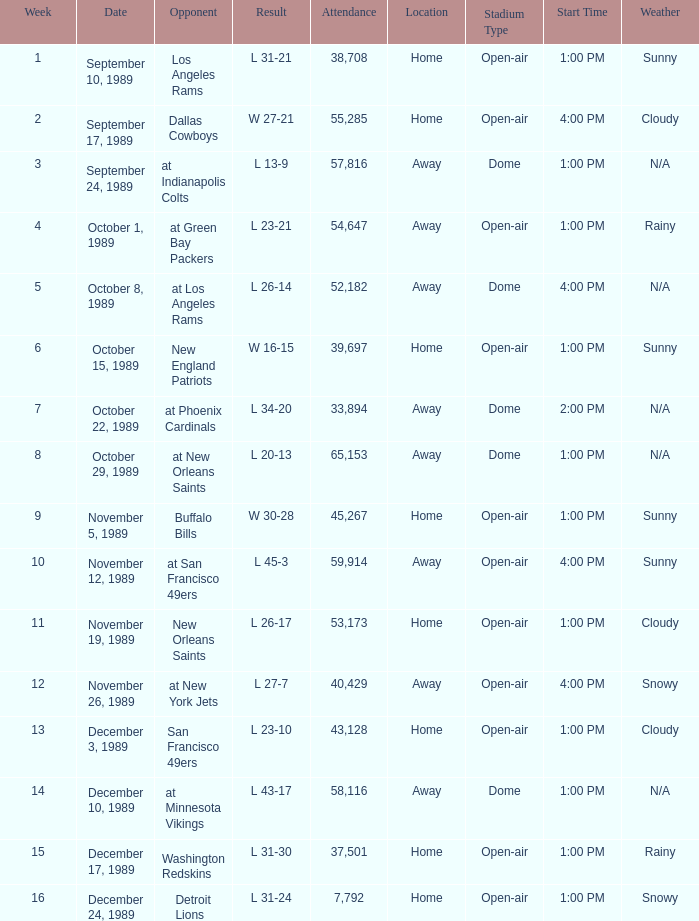For what week was the attendance 40,429? 12.0. Can you give me this table as a dict? {'header': ['Week', 'Date', 'Opponent', 'Result', 'Attendance', 'Location', 'Stadium Type', 'Start Time', 'Weather'], 'rows': [['1', 'September 10, 1989', 'Los Angeles Rams', 'L 31-21', '38,708', 'Home', 'Open-air', '1:00 PM', 'Sunny'], ['2', 'September 17, 1989', 'Dallas Cowboys', 'W 27-21', '55,285', 'Home', 'Open-air', '4:00 PM', 'Cloudy'], ['3', 'September 24, 1989', 'at Indianapolis Colts', 'L 13-9', '57,816', 'Away', 'Dome', '1:00 PM', 'N/A'], ['4', 'October 1, 1989', 'at Green Bay Packers', 'L 23-21', '54,647', 'Away', 'Open-air', '1:00 PM', 'Rainy'], ['5', 'October 8, 1989', 'at Los Angeles Rams', 'L 26-14', '52,182', 'Away', 'Dome', '4:00 PM', 'N/A'], ['6', 'October 15, 1989', 'New England Patriots', 'W 16-15', '39,697', 'Home', 'Open-air', '1:00 PM', 'Sunny'], ['7', 'October 22, 1989', 'at Phoenix Cardinals', 'L 34-20', '33,894', 'Away', 'Dome', '2:00 PM', 'N/A'], ['8', 'October 29, 1989', 'at New Orleans Saints', 'L 20-13', '65,153', 'Away', 'Dome', '1:00 PM', 'N/A'], ['9', 'November 5, 1989', 'Buffalo Bills', 'W 30-28', '45,267', 'Home', 'Open-air', '1:00 PM', 'Sunny'], ['10', 'November 12, 1989', 'at San Francisco 49ers', 'L 45-3', '59,914', 'Away', 'Open-air', '4:00 PM', 'Sunny'], ['11', 'November 19, 1989', 'New Orleans Saints', 'L 26-17', '53,173', 'Home', 'Open-air', '1:00 PM', 'Cloudy'], ['12', 'November 26, 1989', 'at New York Jets', 'L 27-7', '40,429', 'Away', 'Open-air', '4:00 PM', 'Snowy'], ['13', 'December 3, 1989', 'San Francisco 49ers', 'L 23-10', '43,128', 'Home', 'Open-air', '1:00 PM', 'Cloudy'], ['14', 'December 10, 1989', 'at Minnesota Vikings', 'L 43-17', '58,116', 'Away', 'Dome', '1:00 PM', 'N/A'], ['15', 'December 17, 1989', 'Washington Redskins', 'L 31-30', '37,501', 'Home', 'Open-air', '1:00 PM', 'Rainy'], ['16', 'December 24, 1989', 'Detroit Lions', 'L 31-24', '7,792', 'Home', 'Open-air', '1:00 PM', 'Snowy']]} 